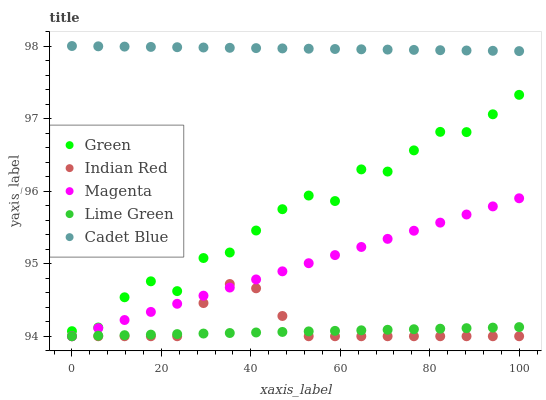Does Lime Green have the minimum area under the curve?
Answer yes or no. Yes. Does Cadet Blue have the maximum area under the curve?
Answer yes or no. Yes. Does Magenta have the minimum area under the curve?
Answer yes or no. No. Does Magenta have the maximum area under the curve?
Answer yes or no. No. Is Lime Green the smoothest?
Answer yes or no. Yes. Is Green the roughest?
Answer yes or no. Yes. Is Magenta the smoothest?
Answer yes or no. No. Is Magenta the roughest?
Answer yes or no. No. Does Lime Green have the lowest value?
Answer yes or no. Yes. Does Cadet Blue have the lowest value?
Answer yes or no. No. Does Cadet Blue have the highest value?
Answer yes or no. Yes. Does Magenta have the highest value?
Answer yes or no. No. Is Indian Red less than Cadet Blue?
Answer yes or no. Yes. Is Cadet Blue greater than Green?
Answer yes or no. Yes. Does Indian Red intersect Lime Green?
Answer yes or no. Yes. Is Indian Red less than Lime Green?
Answer yes or no. No. Is Indian Red greater than Lime Green?
Answer yes or no. No. Does Indian Red intersect Cadet Blue?
Answer yes or no. No. 